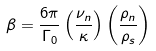<formula> <loc_0><loc_0><loc_500><loc_500>\beta = \frac { 6 \pi } { \Gamma _ { 0 } } \left ( \frac { \nu _ { n } } { \kappa } \right ) \left ( \frac { \rho _ { n } } { \rho _ { s } } \right )</formula> 